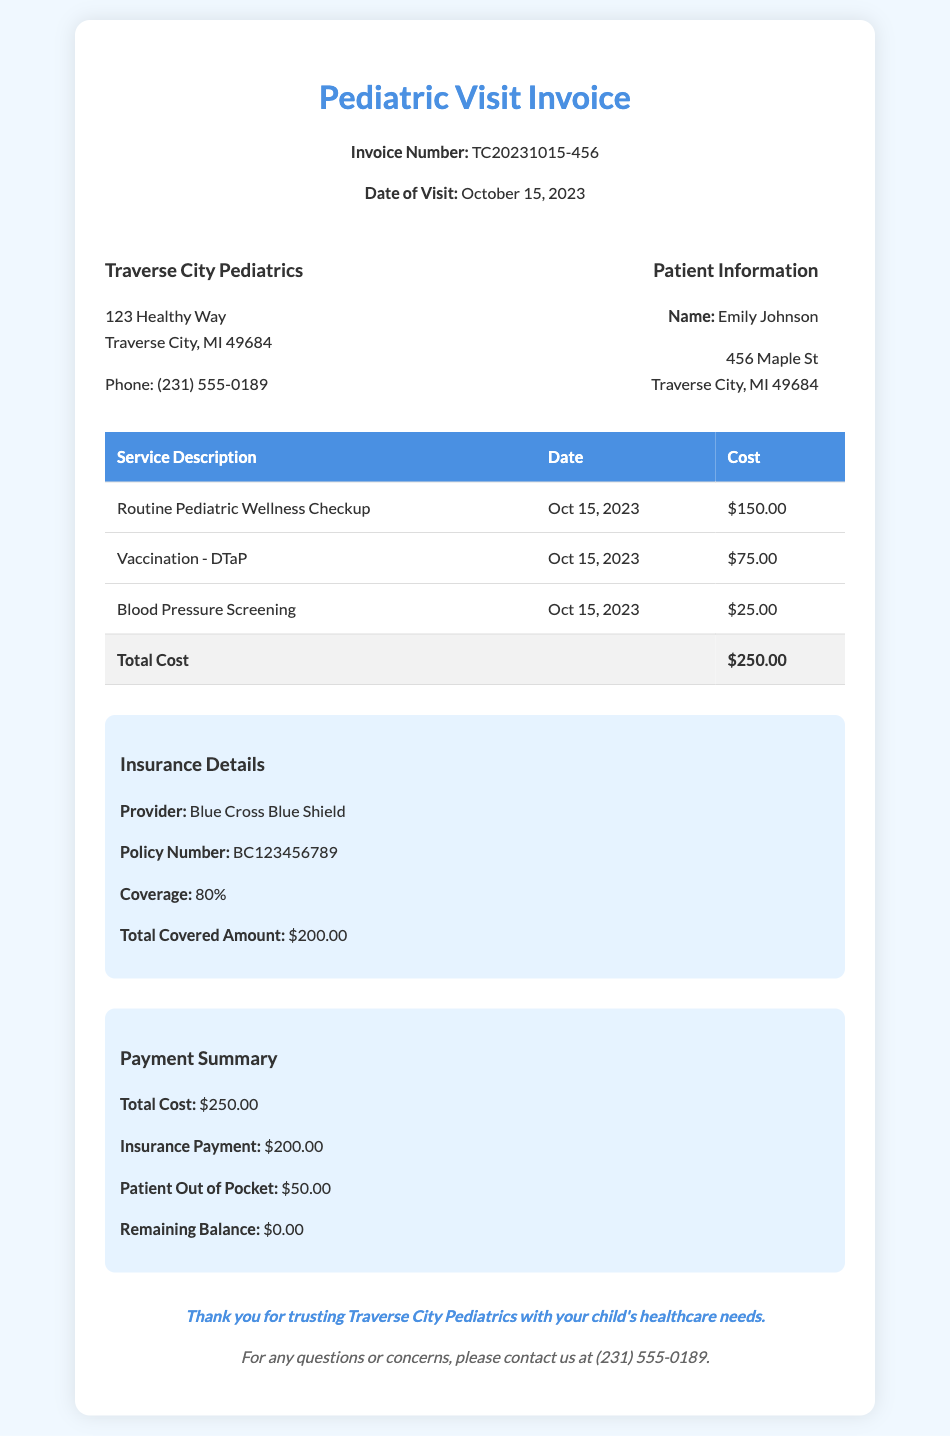What is the total cost of services? The total cost is calculated by adding up all the individual service costs listed in the document, which is $150.00 + $75.00 + $25.00 = $250.00.
Answer: $250.00 Who is the insurance provider? The document lists the insurance provider as Blue Cross Blue Shield, indicated in the insurance details section.
Answer: Blue Cross Blue Shield What is the remaining balance? The remaining balance is shown in the payment summary section, representing the amount still owed after insurance payment, which is $0.00.
Answer: $0.00 How much is the insurance payment? The payment summary specifies that the insurance payment made for the services rendered is $200.00.
Answer: $200.00 What was the date of the visit? The invoice specifies the date of the visit in the header as October 15, 2023.
Answer: October 15, 2023 What services were rendered on the date? The services provided on that date include a Routine Pediatric Wellness Checkup, Vaccination - DTaP, and Blood Pressure Screening, as listed in the services table.
Answer: Routine Pediatric Wellness Checkup, Vaccination - DTaP, Blood Pressure Screening What was the patient’s out-of-pocket cost? The payment summary indicates the out-of-pocket cost for the patient is $50.00 after accounting for the insurance payment.
Answer: $50.00 What is the policy number? The insurance details section lists the policy number as BC123456789.
Answer: BC123456789 